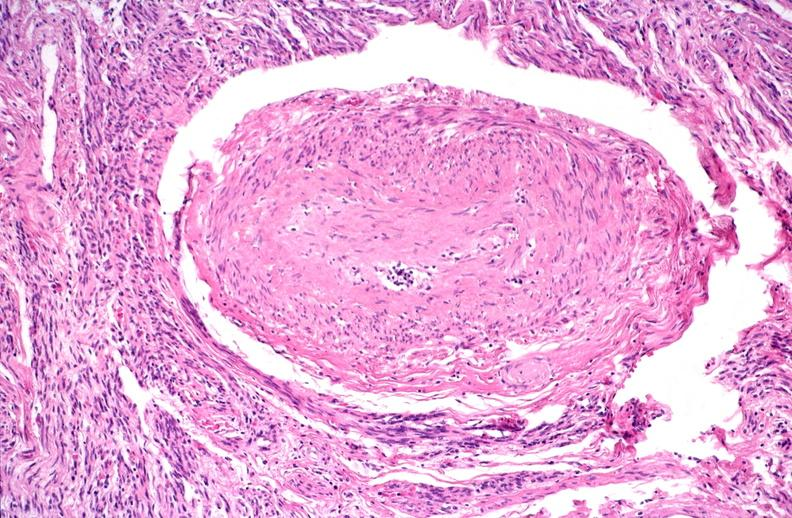does this image show kidney, polyarteritis nodosa?
Answer the question using a single word or phrase. Yes 